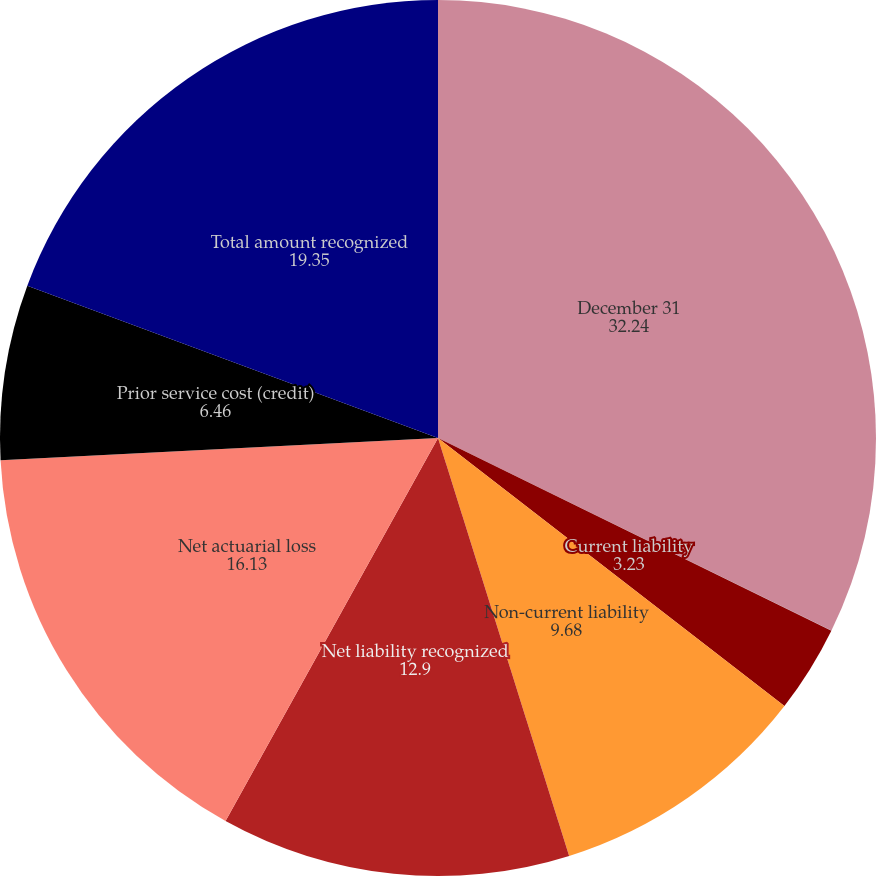Convert chart to OTSL. <chart><loc_0><loc_0><loc_500><loc_500><pie_chart><fcel>December 31<fcel>Non-current asset<fcel>Current liability<fcel>Non-current liability<fcel>Net liability recognized<fcel>Net actuarial loss<fcel>Prior service cost (credit)<fcel>Total amount recognized<nl><fcel>32.24%<fcel>0.01%<fcel>3.23%<fcel>9.68%<fcel>12.9%<fcel>16.13%<fcel>6.46%<fcel>19.35%<nl></chart> 